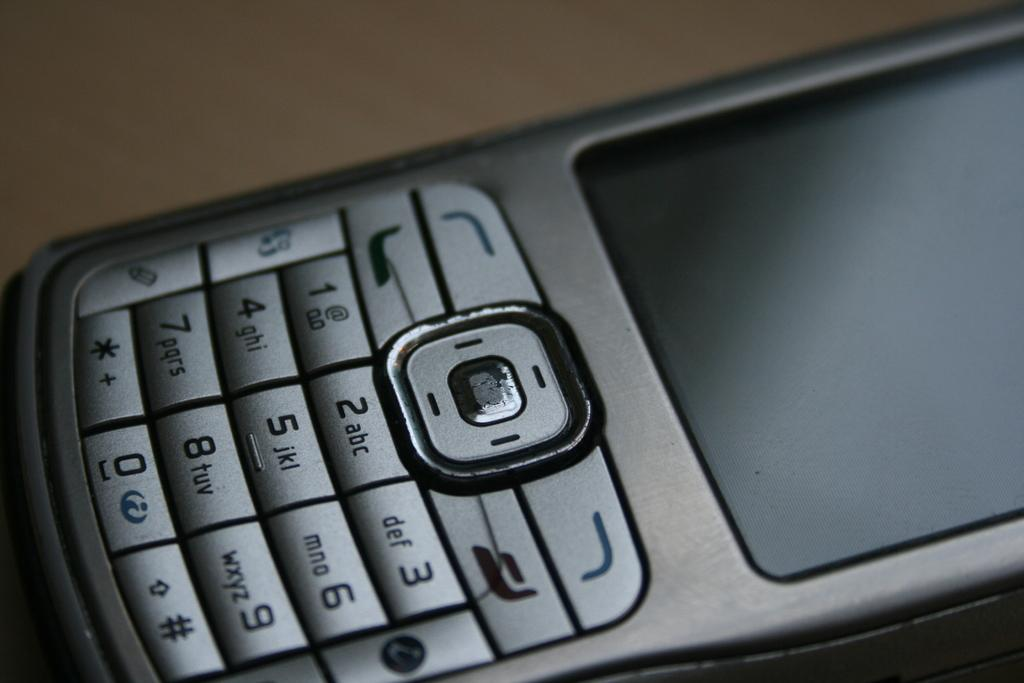<image>
Share a concise interpretation of the image provided. A gray cell phone with the usual numbers and letters like 1, 2, A, B etc on the keys. 